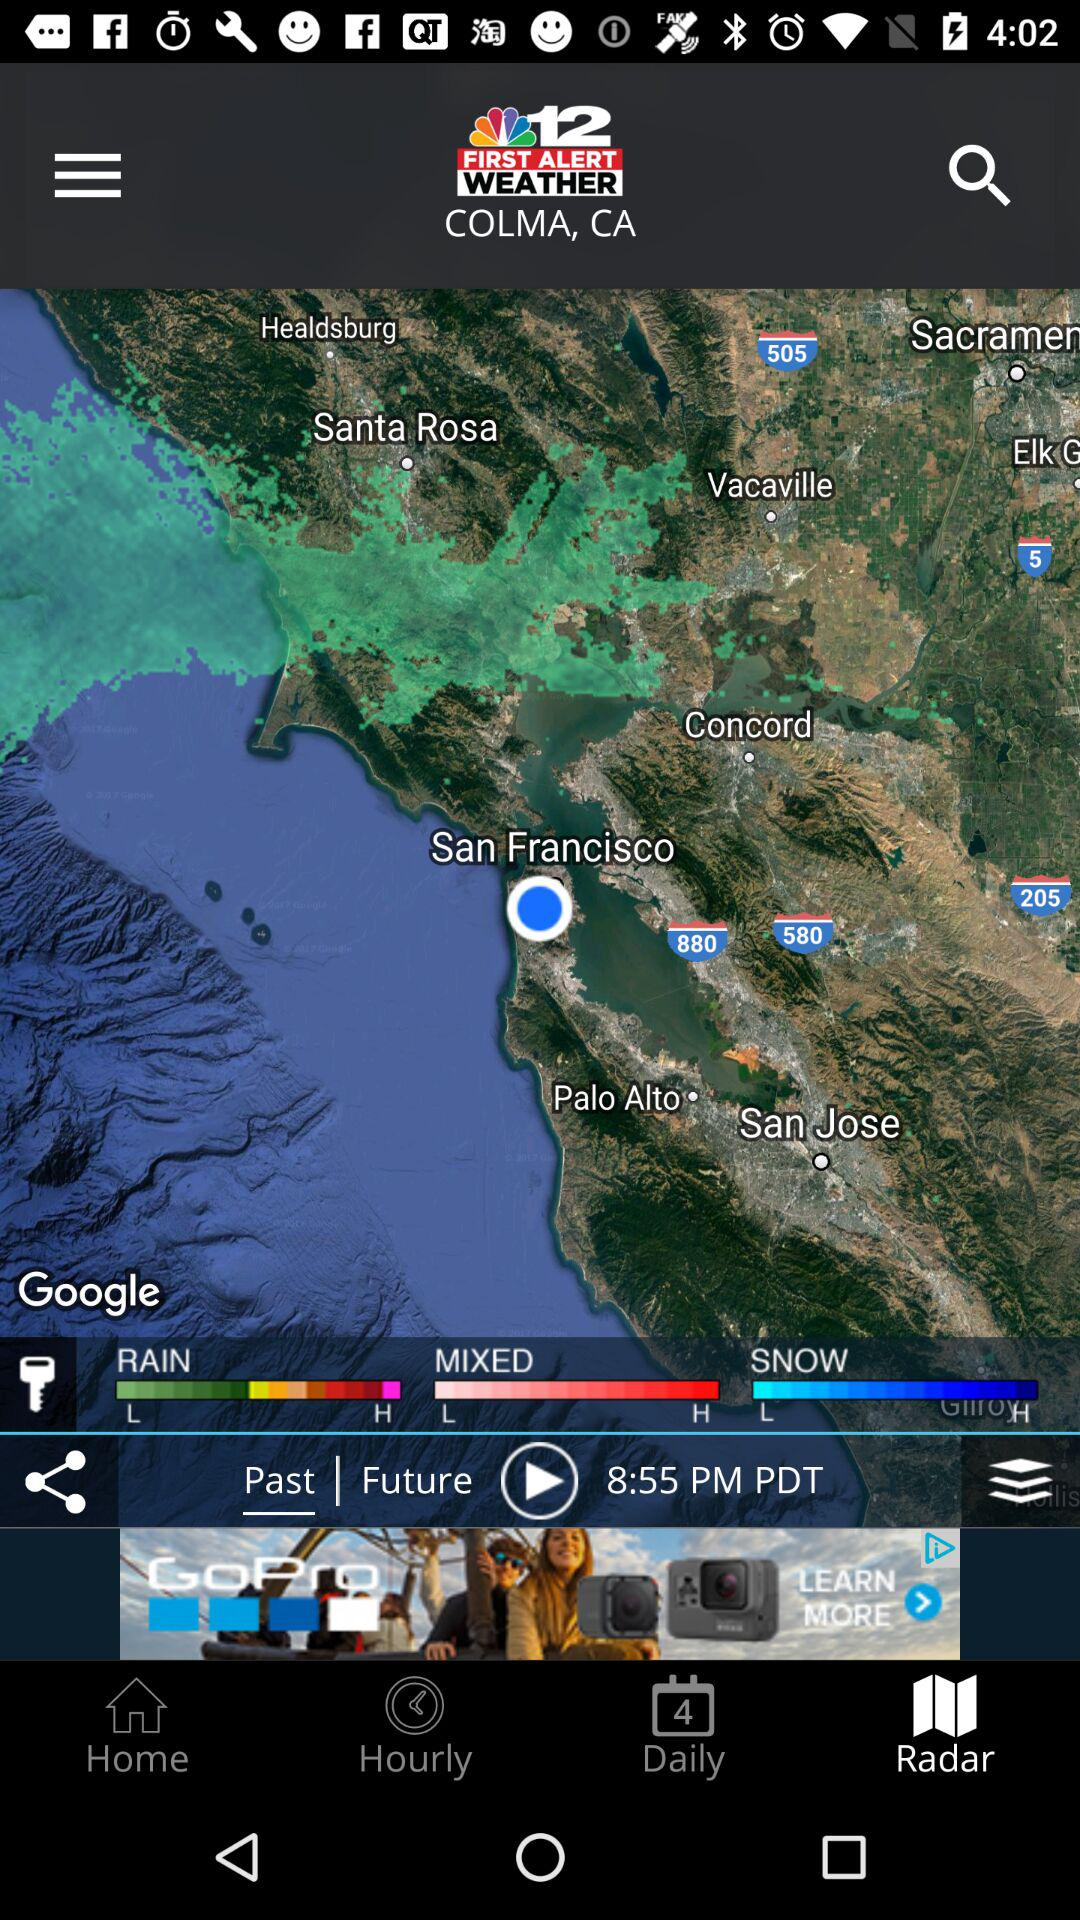How many types of weather are displayed?
Answer the question using a single word or phrase. 3 